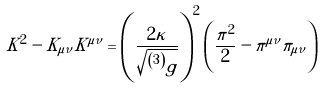<formula> <loc_0><loc_0><loc_500><loc_500>K ^ { 2 } - K _ { \mu \nu } K ^ { \mu \nu } = \left ( \frac { 2 \kappa } { \sqrt { ^ { \left ( 3 \right ) } g } } \right ) ^ { 2 } \left ( \frac { \pi ^ { 2 } } { 2 } - \pi ^ { \mu \nu } \pi _ { \mu \nu } \right )</formula> 